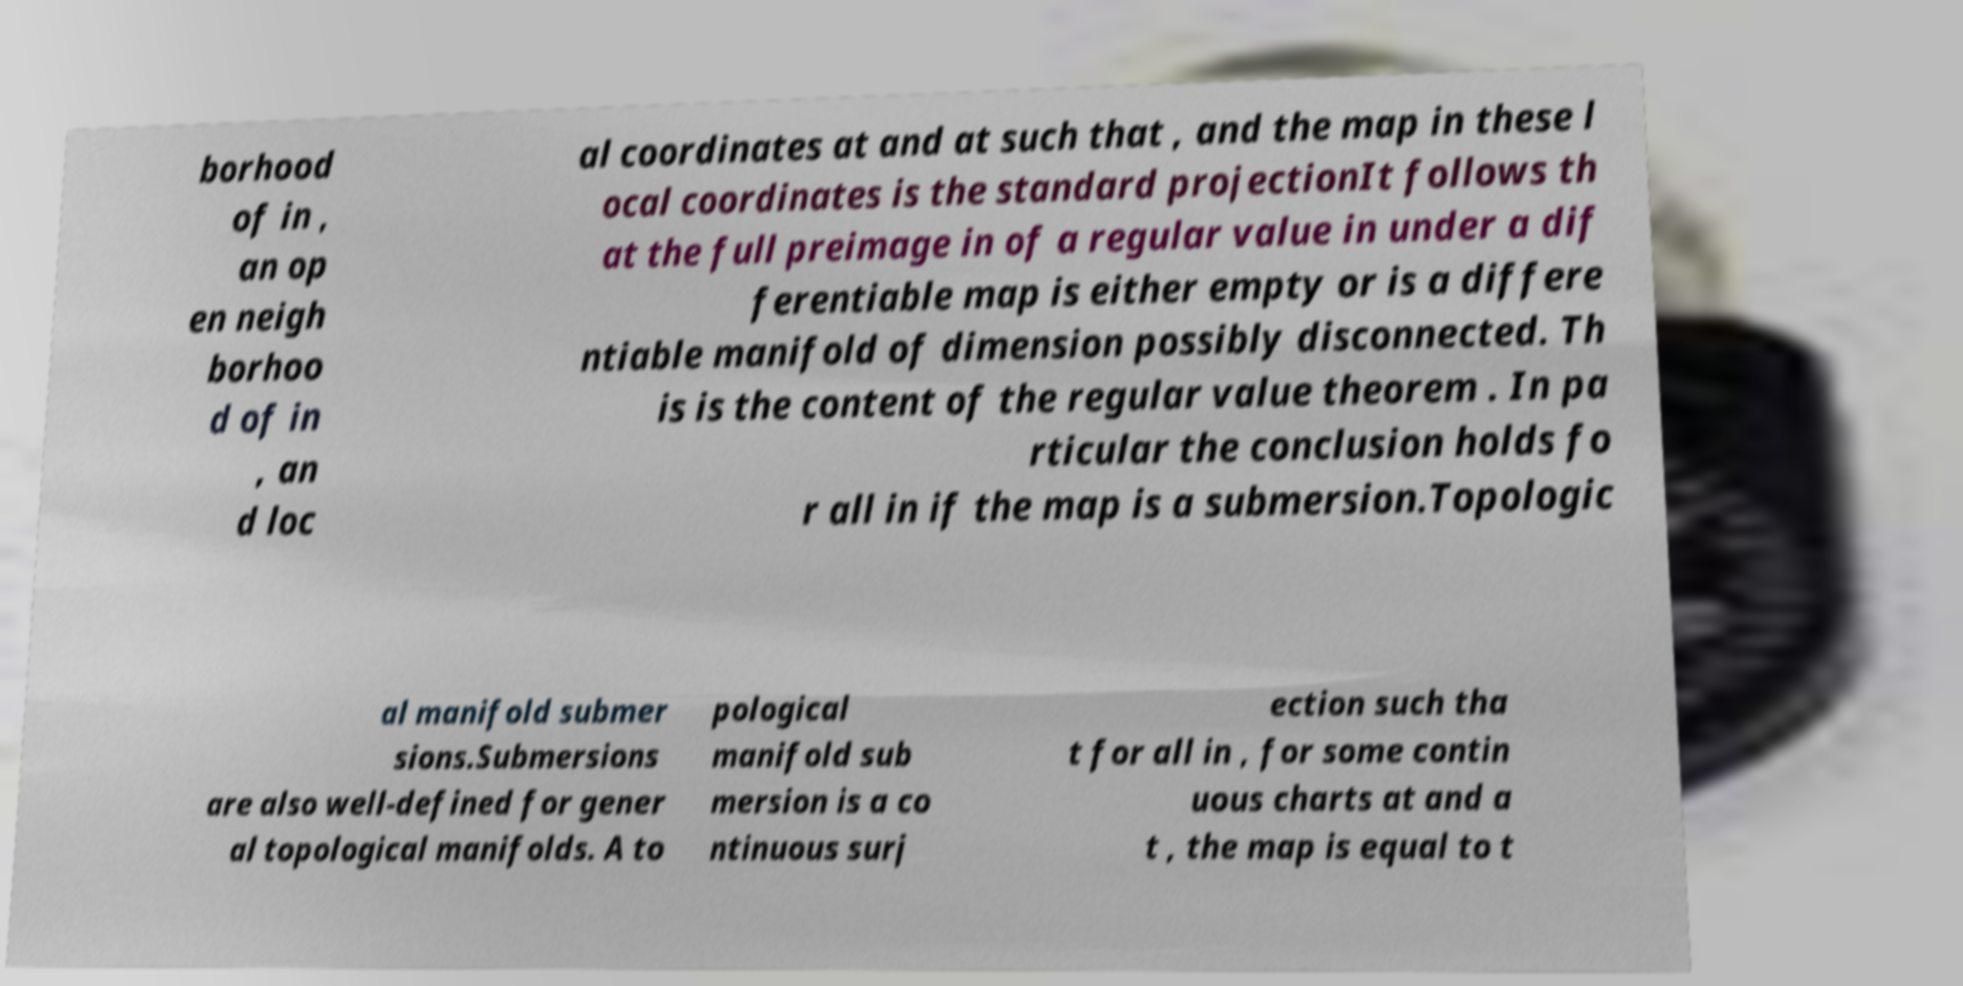Can you read and provide the text displayed in the image?This photo seems to have some interesting text. Can you extract and type it out for me? borhood of in , an op en neigh borhoo d of in , an d loc al coordinates at and at such that , and the map in these l ocal coordinates is the standard projectionIt follows th at the full preimage in of a regular value in under a dif ferentiable map is either empty or is a differe ntiable manifold of dimension possibly disconnected. Th is is the content of the regular value theorem . In pa rticular the conclusion holds fo r all in if the map is a submersion.Topologic al manifold submer sions.Submersions are also well-defined for gener al topological manifolds. A to pological manifold sub mersion is a co ntinuous surj ection such tha t for all in , for some contin uous charts at and a t , the map is equal to t 